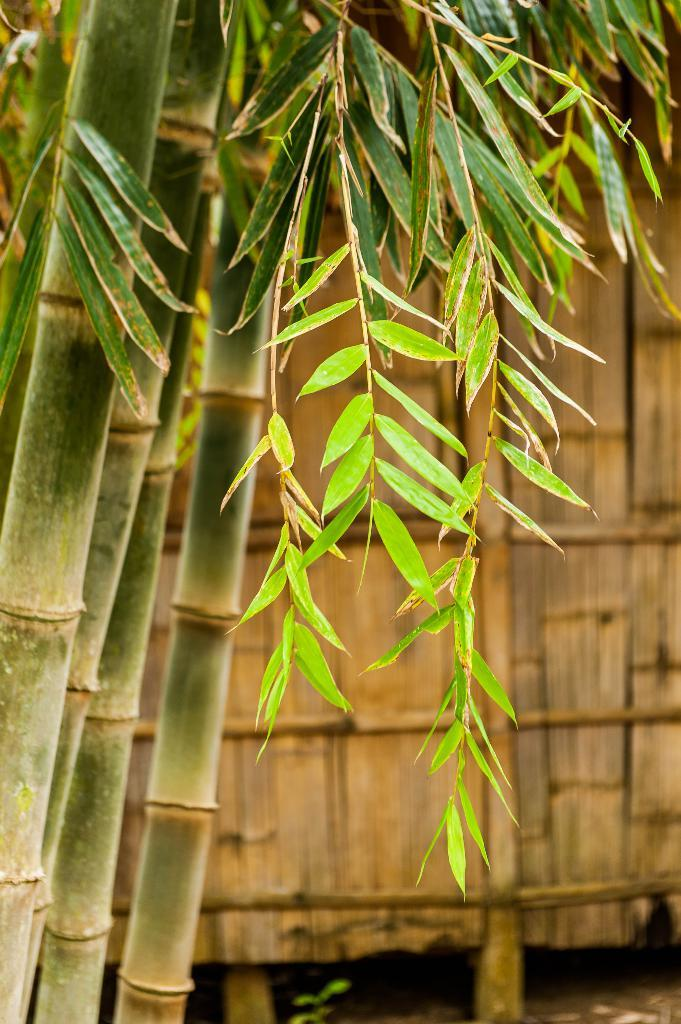What type of vegetation can be seen in the image? There are trees in the image. What type of structure is present in the image? There is a wooden wall in the image. What is the color of the wooden wall? The wooden wall is brown in color. What route can be seen painted on the wooden wall in the image? There is no route painted on the wooden wall in the image; it is simply a brown wooden wall. How many oranges are hanging from the trees in the image? There are no oranges present in the image; only trees are visible. 